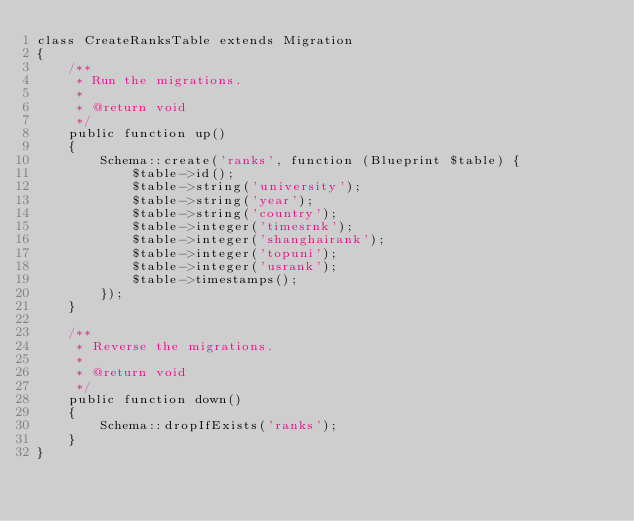Convert code to text. <code><loc_0><loc_0><loc_500><loc_500><_PHP_>class CreateRanksTable extends Migration
{
    /**
     * Run the migrations.
     *
     * @return void
     */
    public function up()
    {
        Schema::create('ranks', function (Blueprint $table) {
            $table->id();
            $table->string('university');
            $table->string('year');
            $table->string('country');
            $table->integer('timesrnk');
            $table->integer('shanghairank');
            $table->integer('topuni');
            $table->integer('usrank');
            $table->timestamps();
        });
    }

    /**
     * Reverse the migrations.
     *
     * @return void
     */
    public function down()
    {
        Schema::dropIfExists('ranks');
    }
}
</code> 